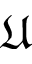<formula> <loc_0><loc_0><loc_500><loc_500>\mathfrak { U }</formula> 